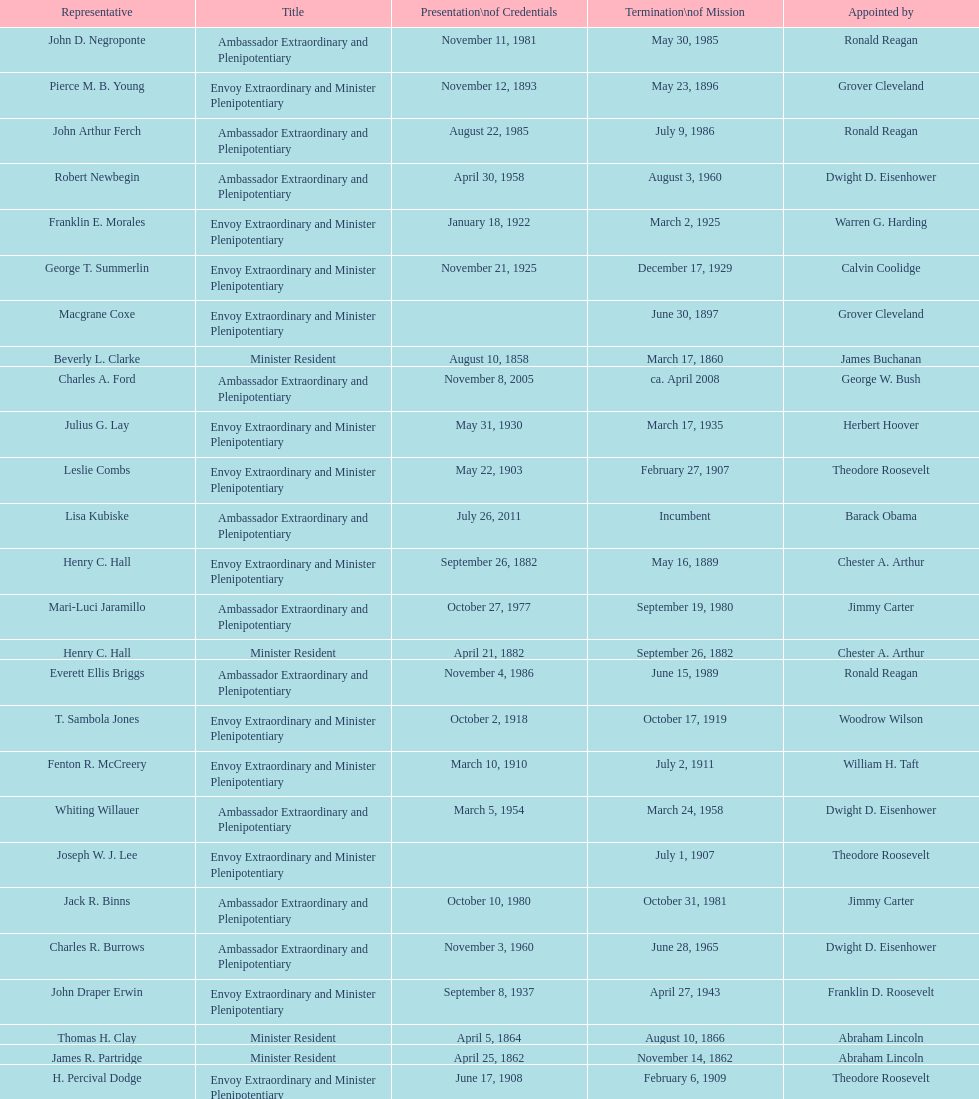Which minister resident had the shortest appointment? Henry C. Hall. 